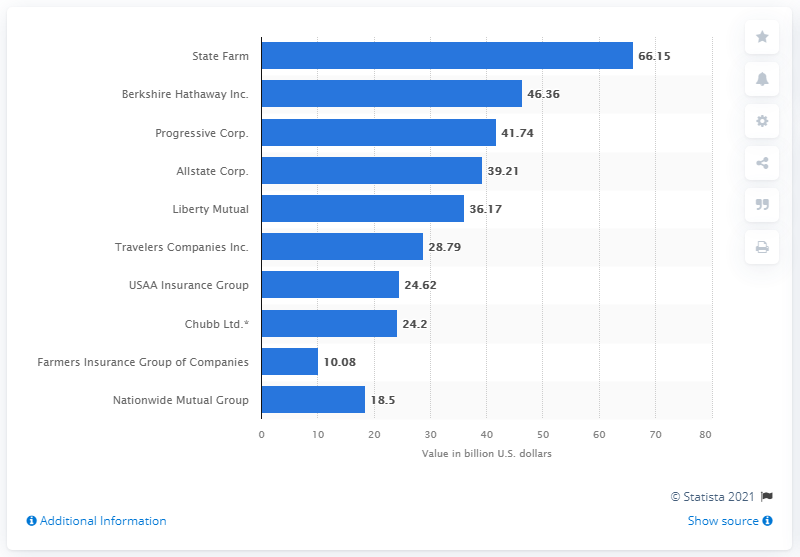Draw attention to some important aspects in this diagram. In 2020, State Farm wrote direct property and casualty reinsurance premiums for businesses with a total value of over 66 billion U.S. dollars. In 2020, State Farm wrote direct property and casualty reinsurance premiums worth $66.15 billion for businesses. 